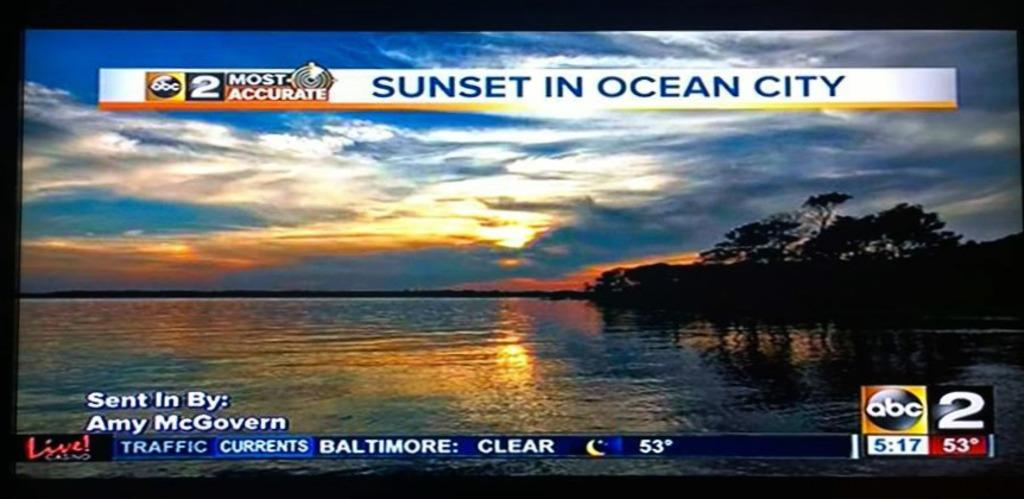Provide a one-sentence caption for the provided image. A TV screen featuring a sunset in Ocean City. 